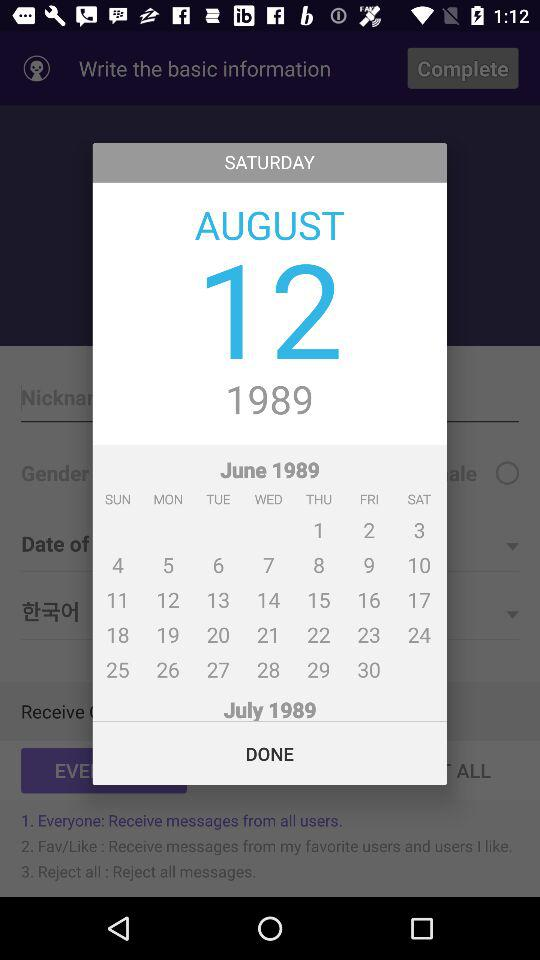What is the day on the 2nd of June? The day on the 2nd of June is Friday. 